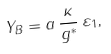Convert formula to latex. <formula><loc_0><loc_0><loc_500><loc_500>Y _ { B } = a \, \frac { \kappa } { g ^ { \ast } } \, \varepsilon _ { 1 } ,</formula> 